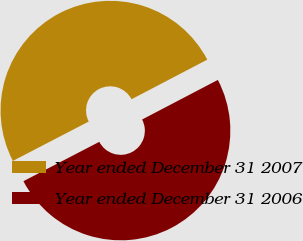Convert chart. <chart><loc_0><loc_0><loc_500><loc_500><pie_chart><fcel>Year ended December 31 2007<fcel>Year ended December 31 2006<nl><fcel>49.95%<fcel>50.05%<nl></chart> 